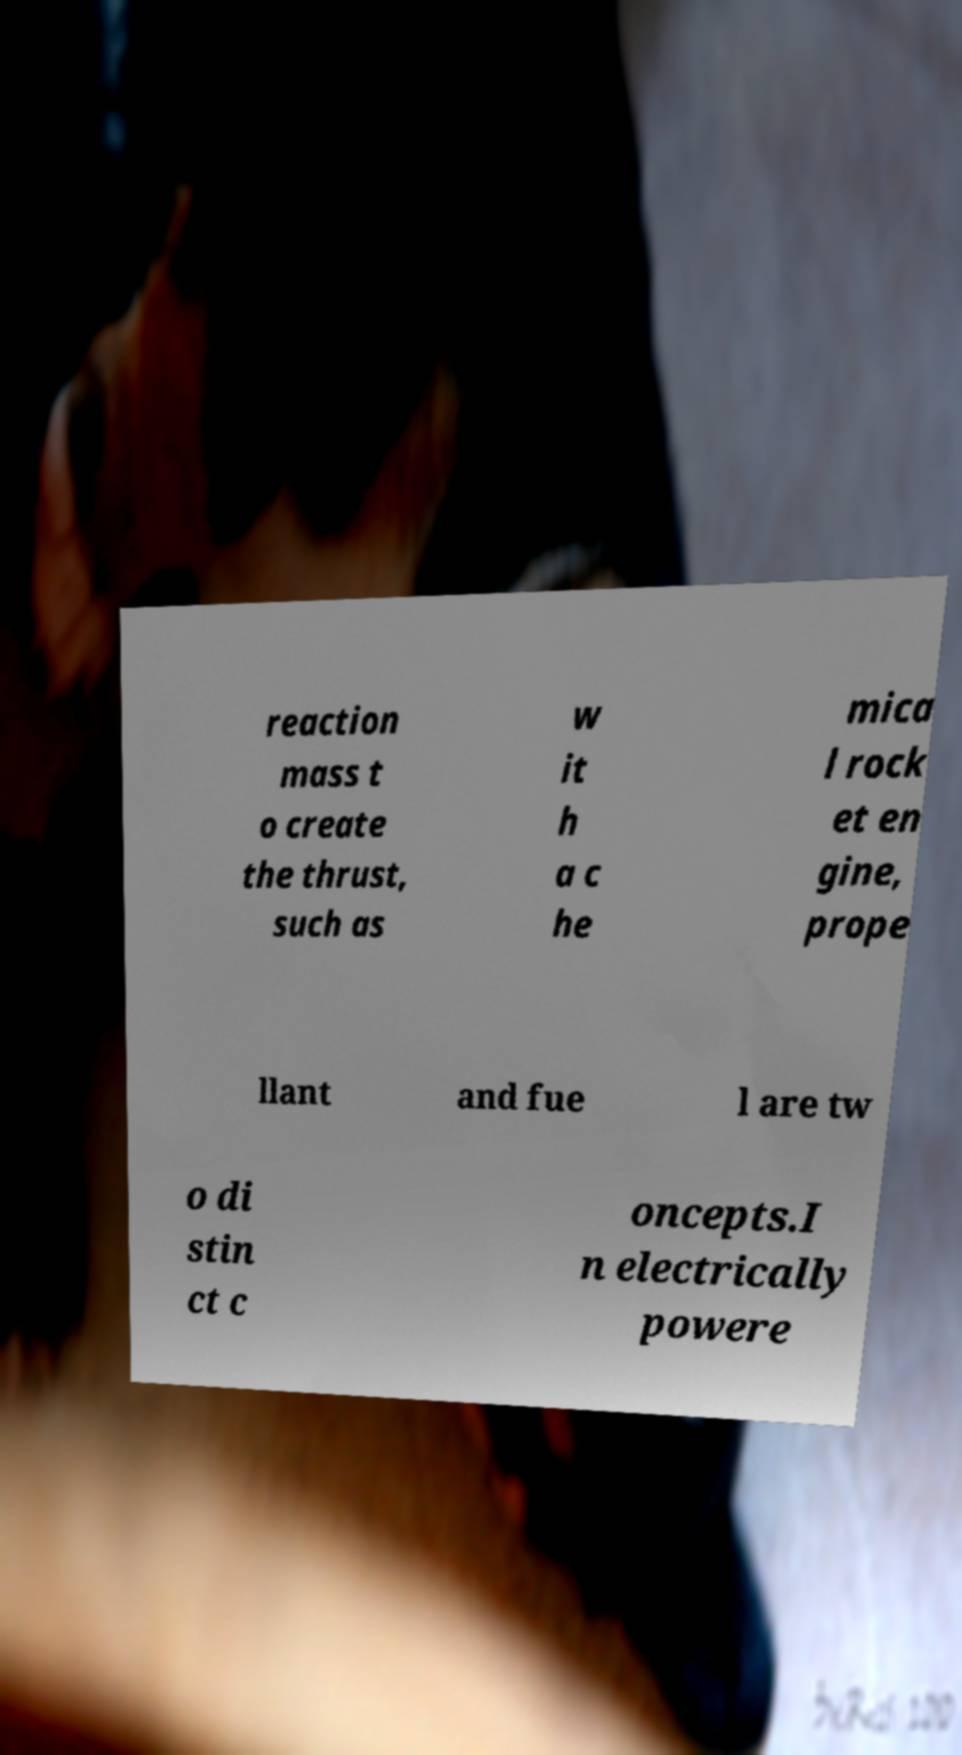Could you assist in decoding the text presented in this image and type it out clearly? reaction mass t o create the thrust, such as w it h a c he mica l rock et en gine, prope llant and fue l are tw o di stin ct c oncepts.I n electrically powere 